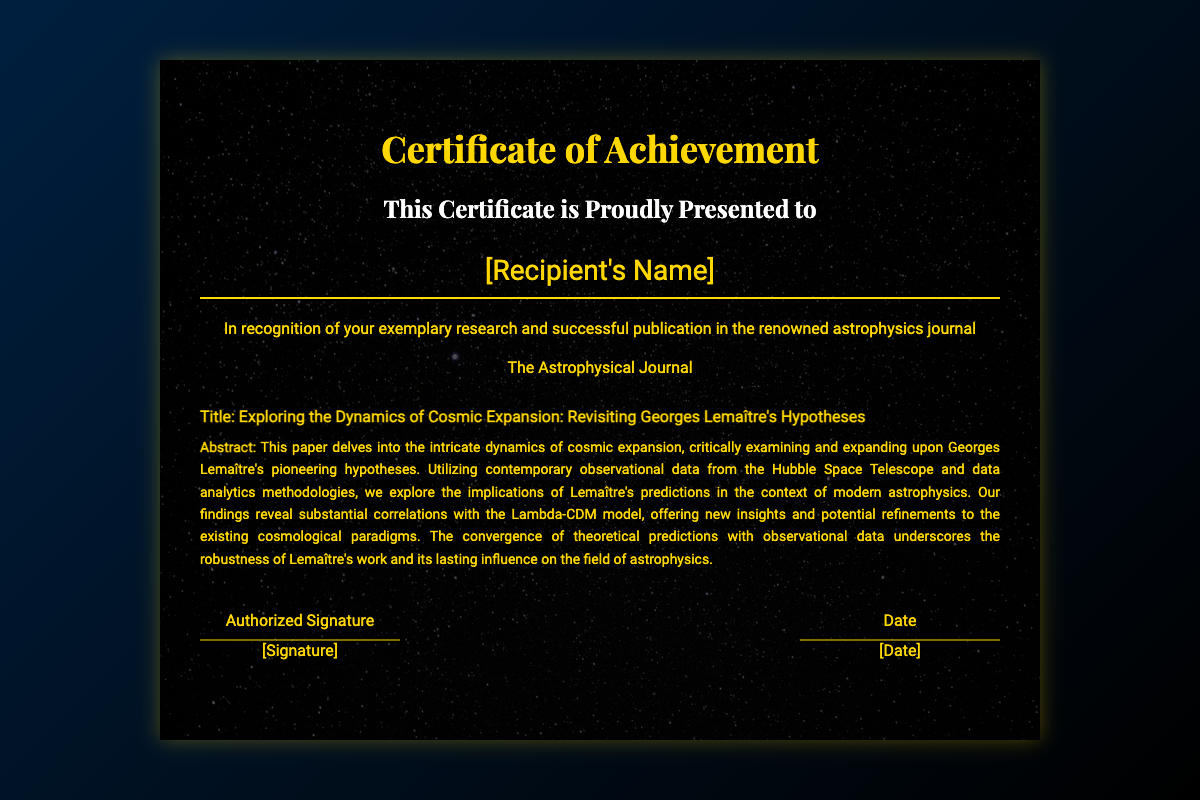What is the title of the paper published? The title of the paper is explicitly stated in the document under "paper-title."
Answer: Exploring the Dynamics of Cosmic Expansion: Revisiting Georges Lemaître's Hypotheses What journal was the paper published in? The document mentions the journal name under "journal."
Answer: The Astrophysical Journal What is the recipient's name? The recipient's name is presented in the document in a section labeled "name."
Answer: [Recipient's Name] What is the core focus of the paper? The abstract summarizes the main focus of the research regarding cosmic expansion and Lemaître's hypotheses outlined in the paper.
Answer: Cosmic expansion dynamics What methodology was utilized in the research? The abstract specifies the use of contemporary observational data and data analytics methodologies in the research.
Answer: Data analytics methodologies What does the abstract reveal about Lemaître's work? The abstract discusses the implications and correlations of Lemaître’s work with the Lambda-CDM model, revealing its lasting influence.
Answer: Lasting influence What is highlighted in the findings of the research? The research findings emphasize substantial correlations between theoretical predictions and observational data, indicating robustness.
Answer: Robustness of Lemaître's work What is the overall theme of the certificate? The theme revolves around recognition for exemplary research and achievement in publishing in a prominent astrophysics journal.
Answer: Recognition for exemplary research What is the aesthetic style of the certificate's background? The background of the certificate features a visually appealing image that complements the theme of astrophysics.
Answer: Astrophysics-themed image 